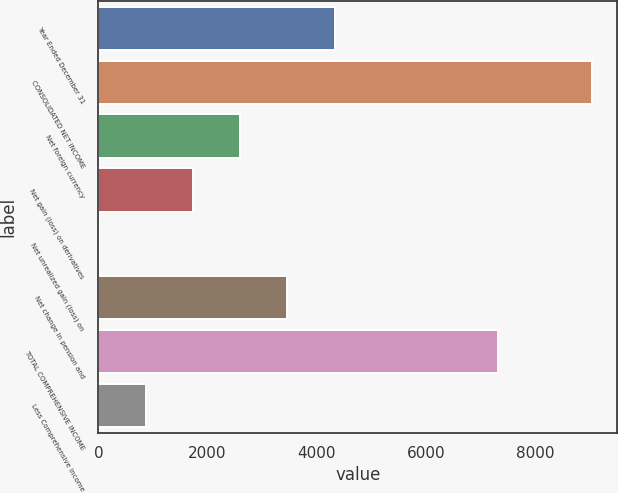Convert chart to OTSL. <chart><loc_0><loc_0><loc_500><loc_500><bar_chart><fcel>Year Ended December 31<fcel>CONSOLIDATED NET INCOME<fcel>Net foreign currency<fcel>Net gain (loss) on derivatives<fcel>Net unrealized gain (loss) on<fcel>Net change in pension and<fcel>TOTAL COMPREHENSIVE INCOME<fcel>Less Comprehensive income<nl><fcel>4326.5<fcel>9046.8<fcel>2598.7<fcel>1734.8<fcel>7<fcel>3462.6<fcel>7319<fcel>870.9<nl></chart> 